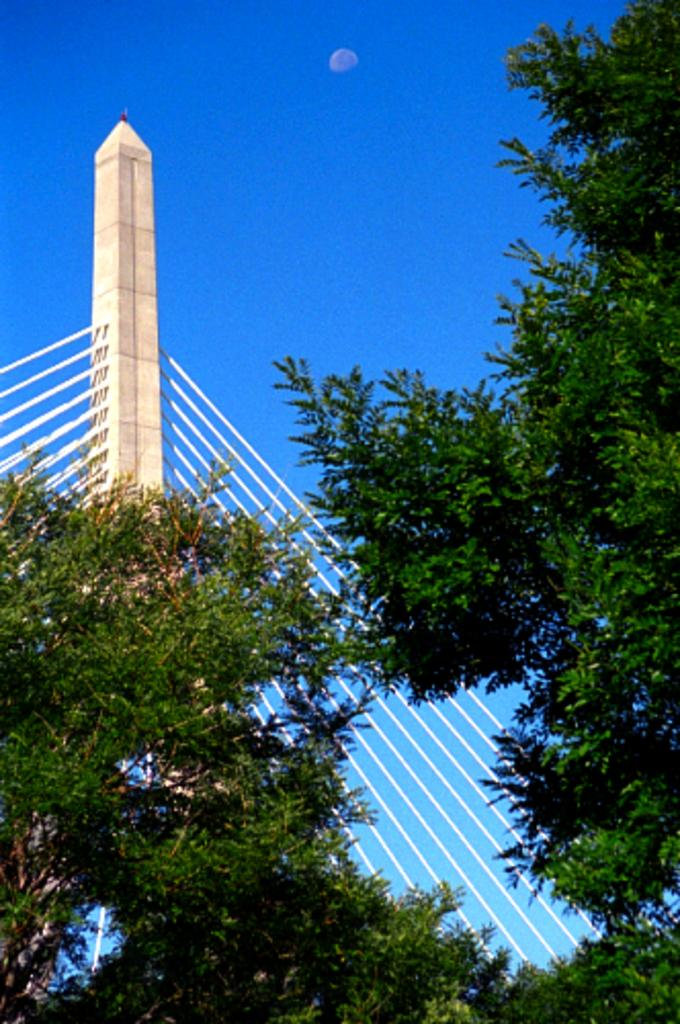What is the main structure visible in the image? There is a tower in the image. What other objects can be seen in the image? There are rods and trees visible in the image. What is visible in the background of the image? The sky is visible in the background of the image. How does the dirt affect the magic in the image? There is no dirt or magic present in the image. 